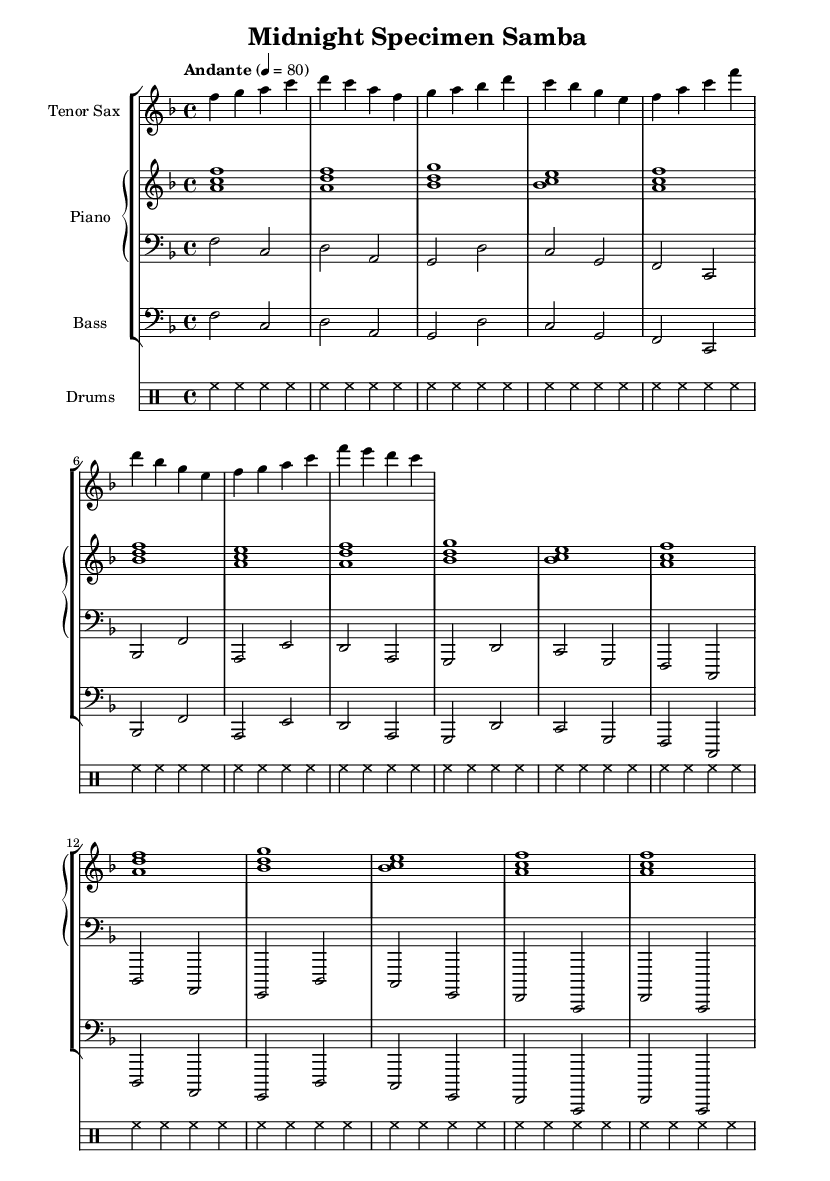What is the key signature of this music? The key signature is F major, indicated by one flat (B flat) in the key signature on the staff.
Answer: F major What is the time signature of this piece? The time signature is 4/4, shown at the beginning of the music with two numbers stacked, signifying four beats in each measure.
Answer: 4/4 What is the tempo marking in this score? The tempo marking is "Andante", which means a moderately slow tempo. The metronome marking given is 80 beats per minute.
Answer: Andante Which instrument has the highest pitch range in this music? The tenor saxophone part is indicated in the treble clef and is typically played in a higher pitch range compared to the piano and bass parts, which are lower.
Answer: Tenor Saxophone How many measures are in the saxophone part? The saxophone part has 8 measures, counted by the distinct groups of notes separated by vertical bar lines.
Answer: 8 measures Which chord is played at the beginning of the piano right hand? The first chord played in the piano right hand is an A minor chord, denoted by the notes A, C, and F played together in the score.
Answer: A minor What type of rhythm pattern is used in the drum part? The drum part consists of a consistent hi-hat rhythm pattern repeated throughout, which can be characterized as steady eighth notes played on a hi-hat.
Answer: Steady eighth notes 